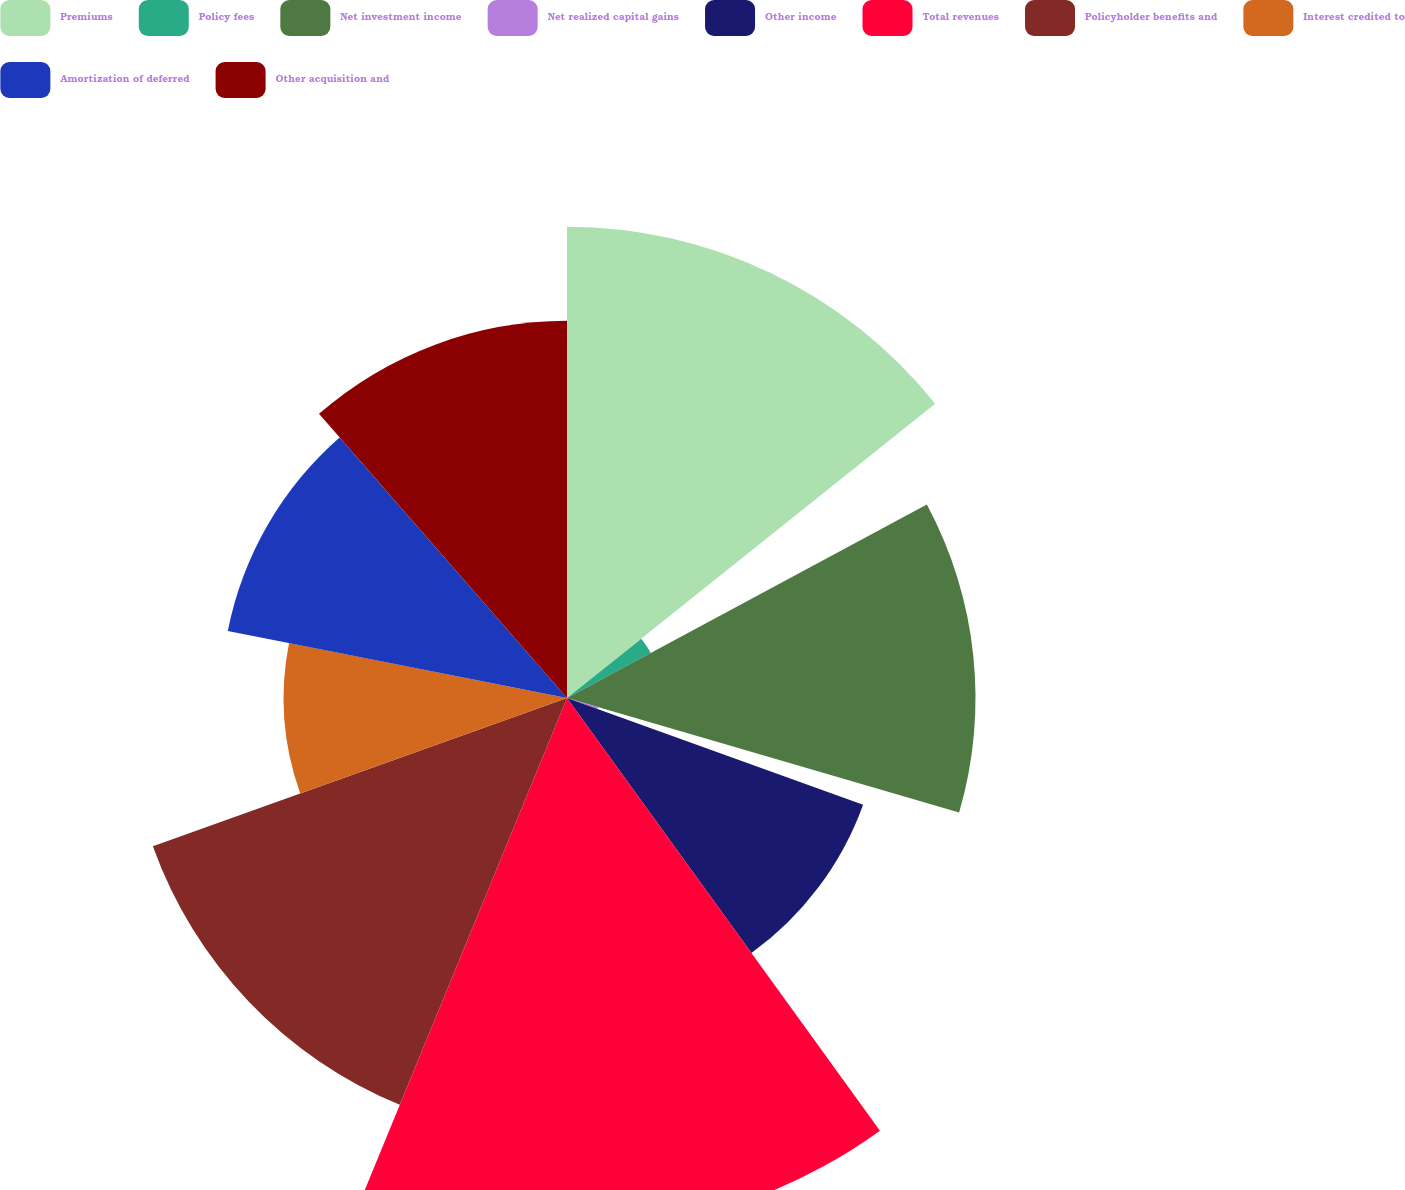<chart> <loc_0><loc_0><loc_500><loc_500><pie_chart><fcel>Premiums<fcel>Policy fees<fcel>Net investment income<fcel>Net realized capital gains<fcel>Other income<fcel>Total revenues<fcel>Policyholder benefits and<fcel>Interest credited to<fcel>Amortization of deferred<fcel>Other acquisition and<nl><fcel>14.27%<fcel>2.88%<fcel>12.37%<fcel>0.98%<fcel>9.53%<fcel>16.17%<fcel>13.32%<fcel>8.58%<fcel>10.47%<fcel>11.42%<nl></chart> 